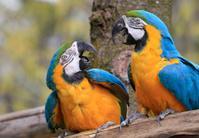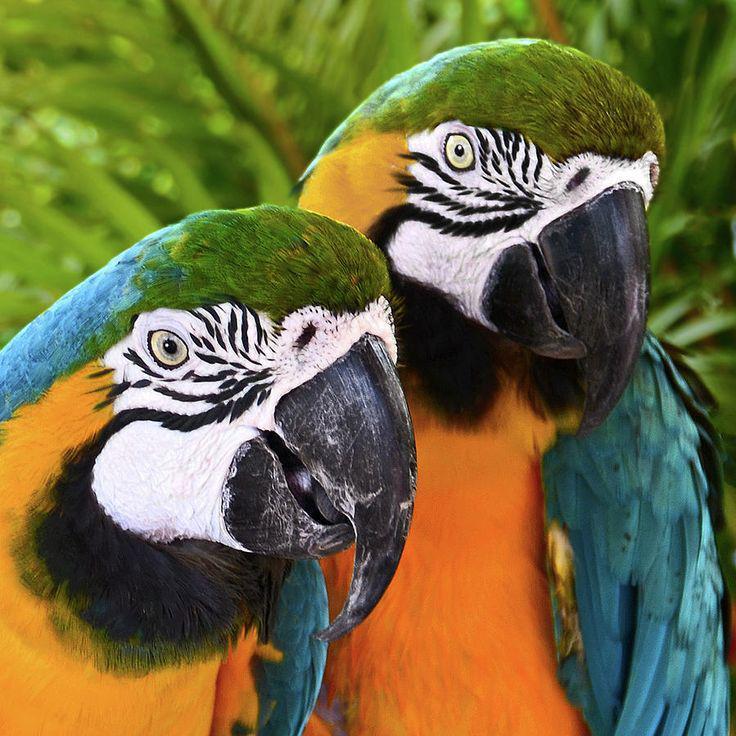The first image is the image on the left, the second image is the image on the right. For the images displayed, is the sentence "One image includes a red-feathered parrot along with a blue-and-yellow parrot." factually correct? Answer yes or no. No. The first image is the image on the left, the second image is the image on the right. Evaluate the accuracy of this statement regarding the images: "Exactly four parrots are shown, two in each image, all of them with the same eye design and gold chests, one pair looking at each other, while one pair looks in the same direction.". Is it true? Answer yes or no. Yes. 